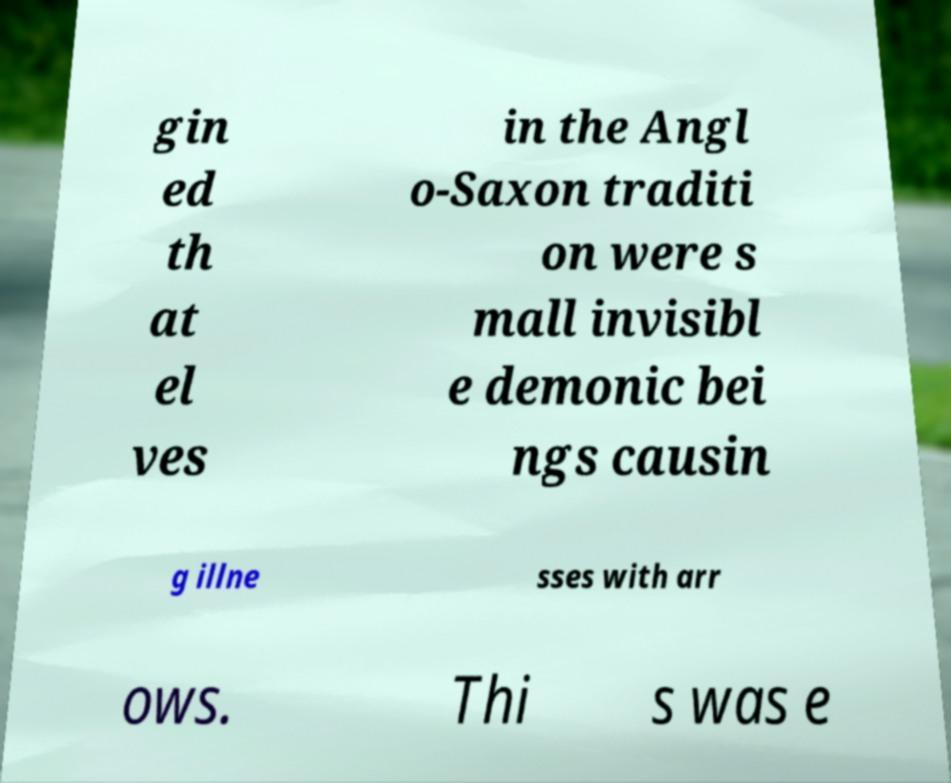Could you assist in decoding the text presented in this image and type it out clearly? gin ed th at el ves in the Angl o-Saxon traditi on were s mall invisibl e demonic bei ngs causin g illne sses with arr ows. Thi s was e 